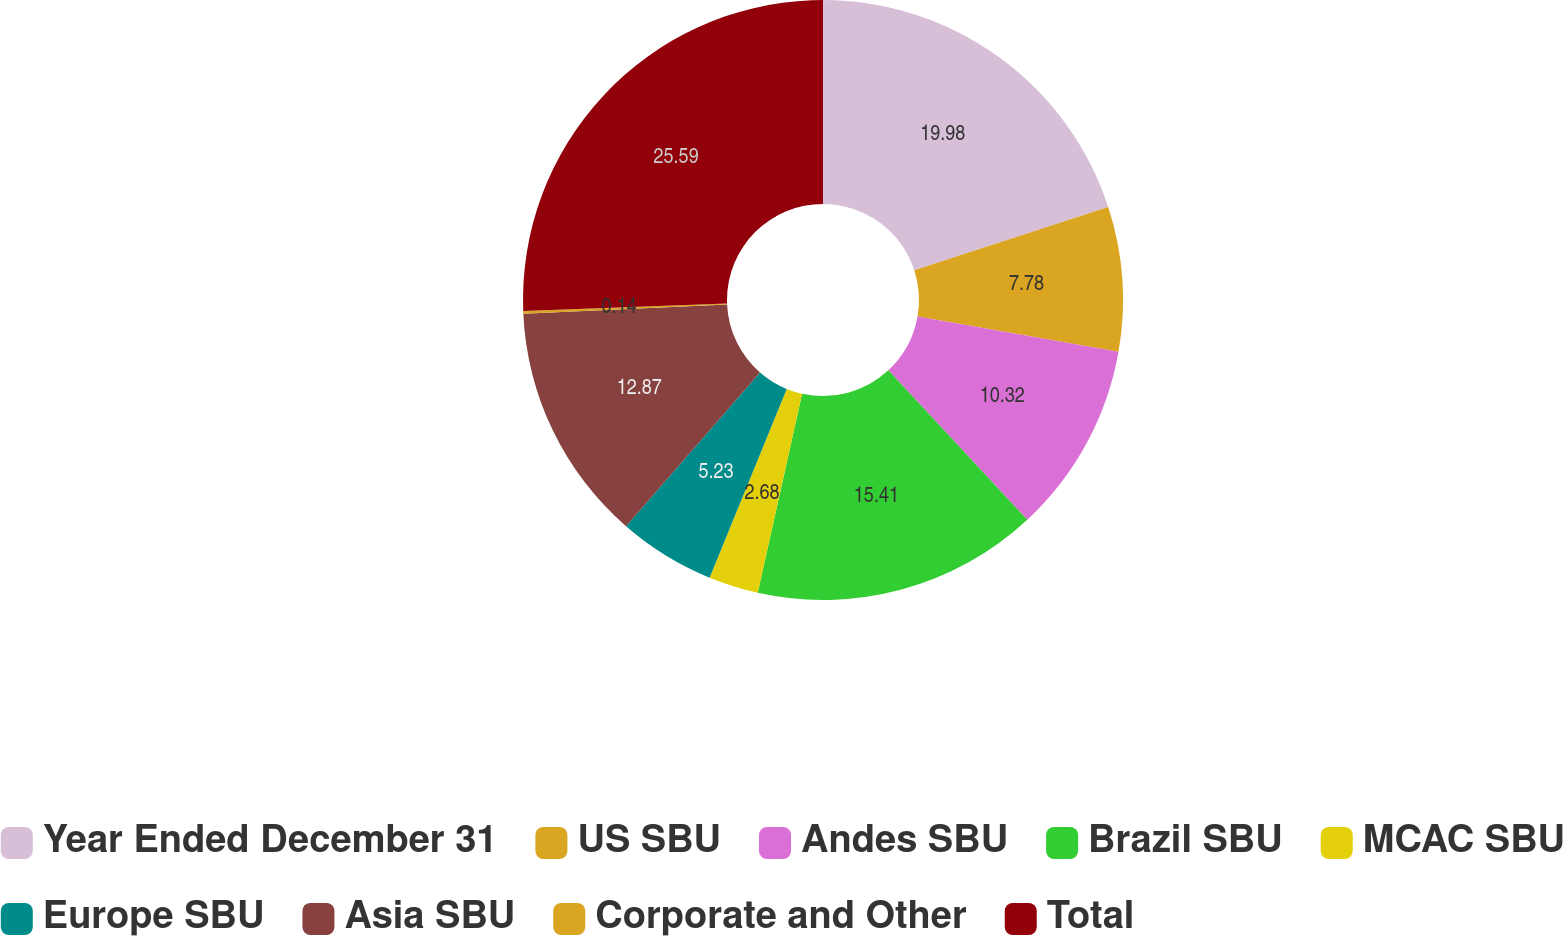Convert chart to OTSL. <chart><loc_0><loc_0><loc_500><loc_500><pie_chart><fcel>Year Ended December 31<fcel>US SBU<fcel>Andes SBU<fcel>Brazil SBU<fcel>MCAC SBU<fcel>Europe SBU<fcel>Asia SBU<fcel>Corporate and Other<fcel>Total<nl><fcel>19.98%<fcel>7.78%<fcel>10.32%<fcel>15.41%<fcel>2.68%<fcel>5.23%<fcel>12.87%<fcel>0.14%<fcel>25.59%<nl></chart> 